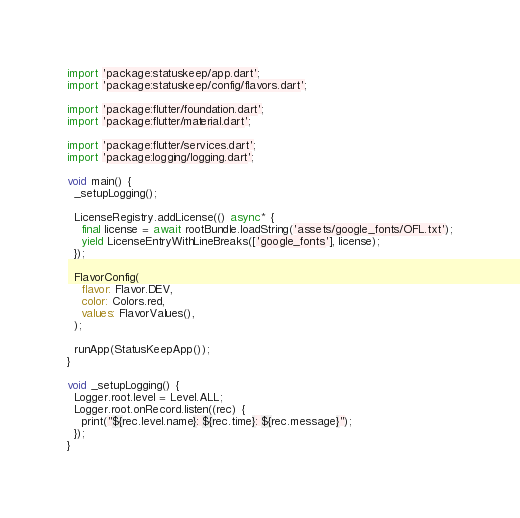Convert code to text. <code><loc_0><loc_0><loc_500><loc_500><_Dart_>import 'package:statuskeep/app.dart';
import 'package:statuskeep/config/flavors.dart';

import 'package:flutter/foundation.dart';
import 'package:flutter/material.dart';

import 'package:flutter/services.dart';
import 'package:logging/logging.dart';

void main() {
  _setupLogging();

  LicenseRegistry.addLicense(() async* {
    final license = await rootBundle.loadString('assets/google_fonts/OFL.txt');
    yield LicenseEntryWithLineBreaks(['google_fonts'], license);
  });

  FlavorConfig(
    flavor: Flavor.DEV,
    color: Colors.red,
    values: FlavorValues(),
  );

  runApp(StatusKeepApp());
}

void _setupLogging() {
  Logger.root.level = Level.ALL;
  Logger.root.onRecord.listen((rec) {
    print("${rec.level.name}: ${rec.time}: ${rec.message}");
  });
}
</code> 